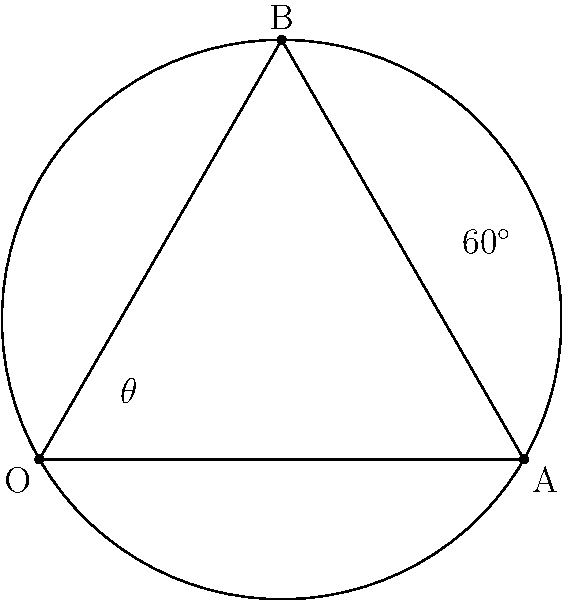In an ancient star map used for navigation by an indigenous Polynesian culture, three stars form an equilateral triangle inscribed in a circle. If the angle $\theta$ at the center of the circle subtends one side of the triangle, what is the value of $\theta$ in degrees? Let's approach this step-by-step:

1) In an equilateral triangle, all sides are equal and all angles are 60°.

2) The triangle is inscribed in a circle, which means it's centered at the circle's center.

3) In a circle, the central angle is twice the inscribed angle that subtends the same arc. This is known as the Inscribed Angle Theorem.

4) One of the triangle's angles (60°) is an inscribed angle in this circle.

5) Therefore, the central angle $\theta$ that subtends the same side of the triangle must be twice this angle.

6) We can express this mathematically as:

   $$\theta = 2 \times 60^\circ = 120^\circ$$

Thus, the central angle $\theta$ is 120°.
Answer: 120° 